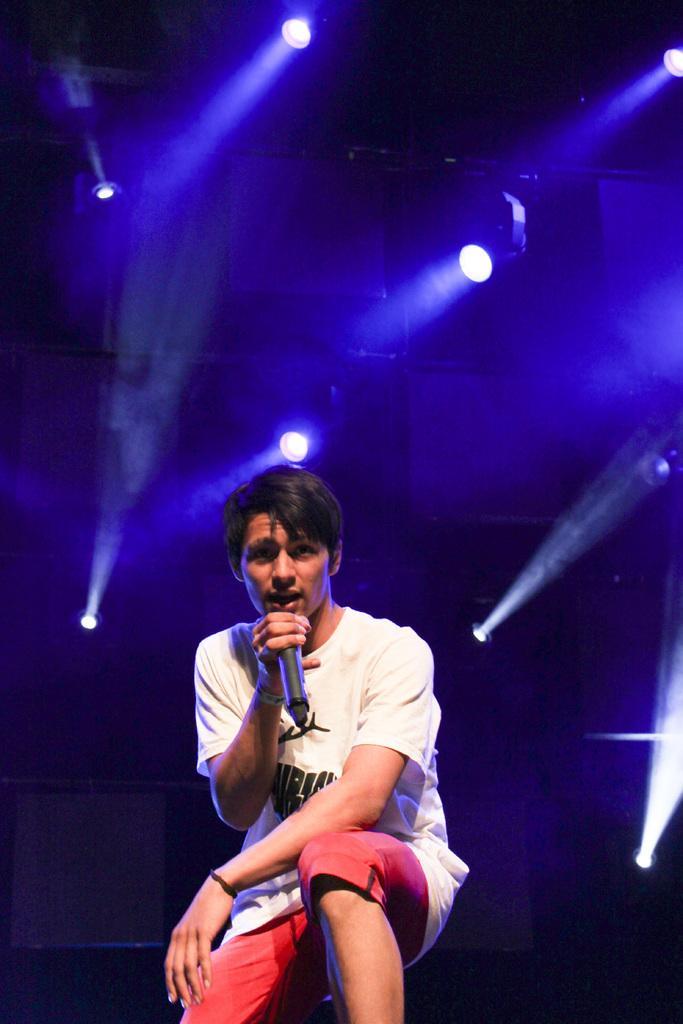Can you describe this image briefly? In this picture we can see a person,he is holding a mic and in the background we can see lights. 